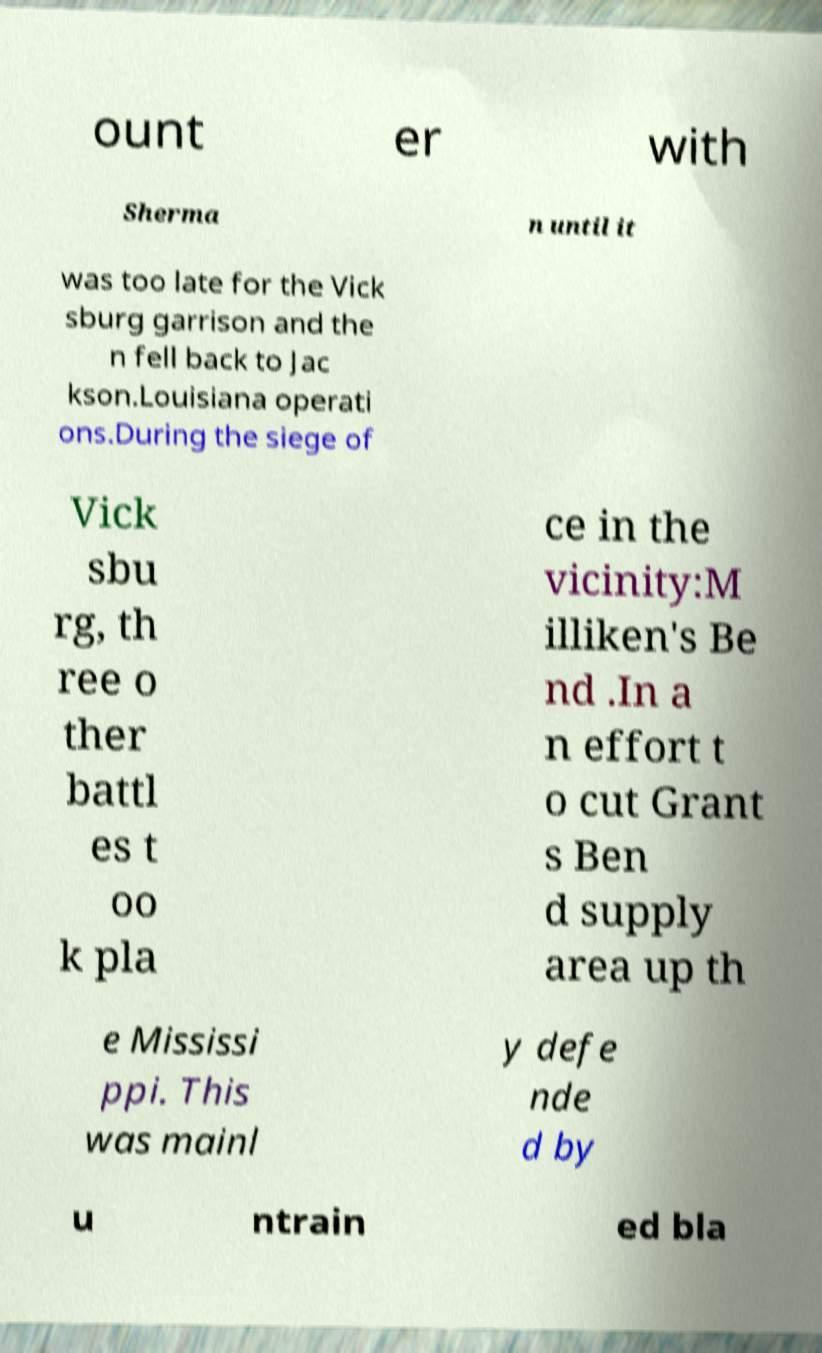Can you accurately transcribe the text from the provided image for me? ount er with Sherma n until it was too late for the Vick sburg garrison and the n fell back to Jac kson.Louisiana operati ons.During the siege of Vick sbu rg, th ree o ther battl es t oo k pla ce in the vicinity:M illiken's Be nd .In a n effort t o cut Grant s Ben d supply area up th e Mississi ppi. This was mainl y defe nde d by u ntrain ed bla 